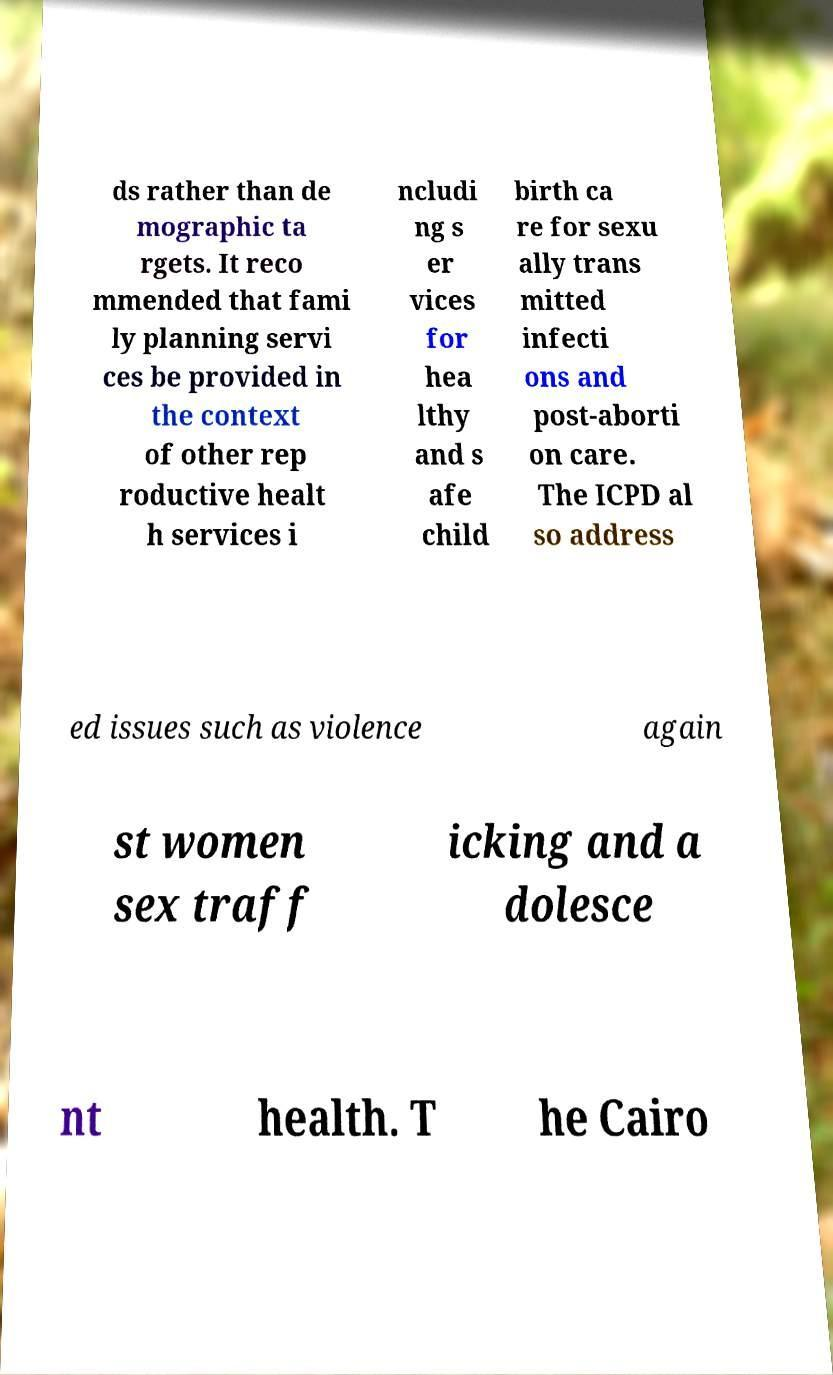Please read and relay the text visible in this image. What does it say? ds rather than de mographic ta rgets. It reco mmended that fami ly planning servi ces be provided in the context of other rep roductive healt h services i ncludi ng s er vices for hea lthy and s afe child birth ca re for sexu ally trans mitted infecti ons and post-aborti on care. The ICPD al so address ed issues such as violence again st women sex traff icking and a dolesce nt health. T he Cairo 